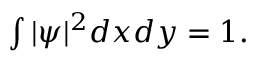Convert formula to latex. <formula><loc_0><loc_0><loc_500><loc_500>\begin{array} { r } { \int | \psi | ^ { 2 } d x d y = 1 . } \end{array}</formula> 